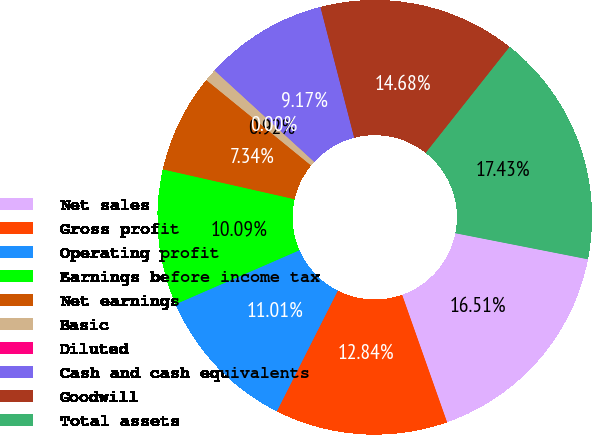Convert chart. <chart><loc_0><loc_0><loc_500><loc_500><pie_chart><fcel>Net sales<fcel>Gross profit<fcel>Operating profit<fcel>Earnings before income tax<fcel>Net earnings<fcel>Basic<fcel>Diluted<fcel>Cash and cash equivalents<fcel>Goodwill<fcel>Total assets<nl><fcel>16.51%<fcel>12.84%<fcel>11.01%<fcel>10.09%<fcel>7.34%<fcel>0.92%<fcel>0.0%<fcel>9.17%<fcel>14.68%<fcel>17.43%<nl></chart> 